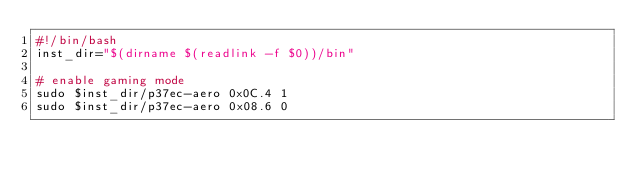Convert code to text. <code><loc_0><loc_0><loc_500><loc_500><_Bash_>#!/bin/bash
inst_dir="$(dirname $(readlink -f $0))/bin"

# enable gaming mode
sudo $inst_dir/p37ec-aero 0x0C.4 1
sudo $inst_dir/p37ec-aero 0x08.6 0
</code> 